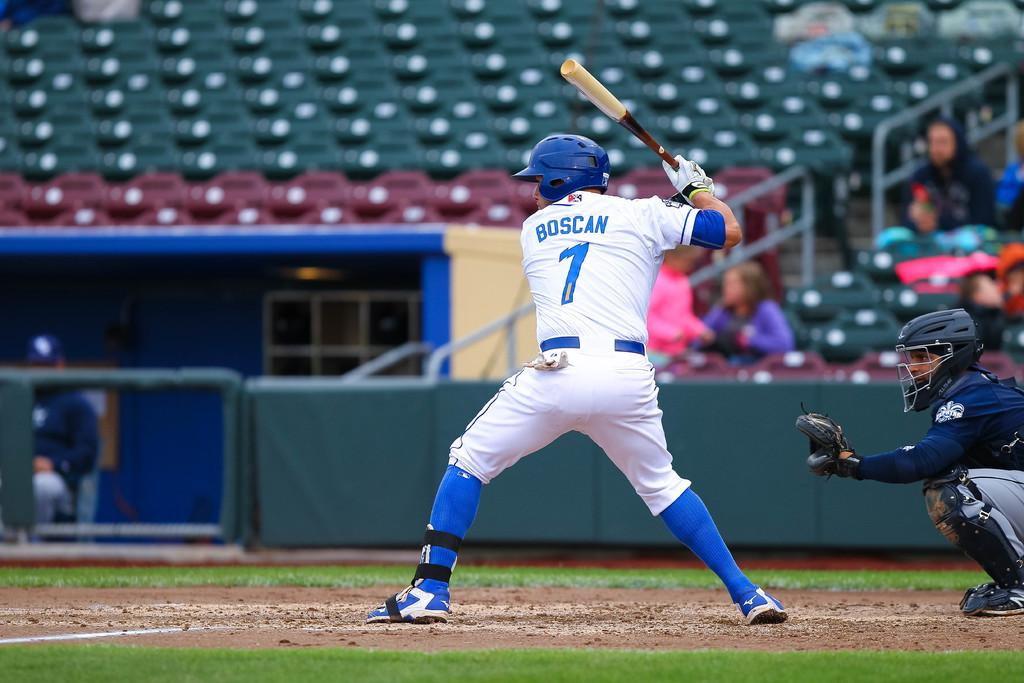<image>
Write a terse but informative summary of the picture. A baseball player called Boscan with a number 7 on hi shsirt readies to hit the ball with the catcher sat just behind him. 